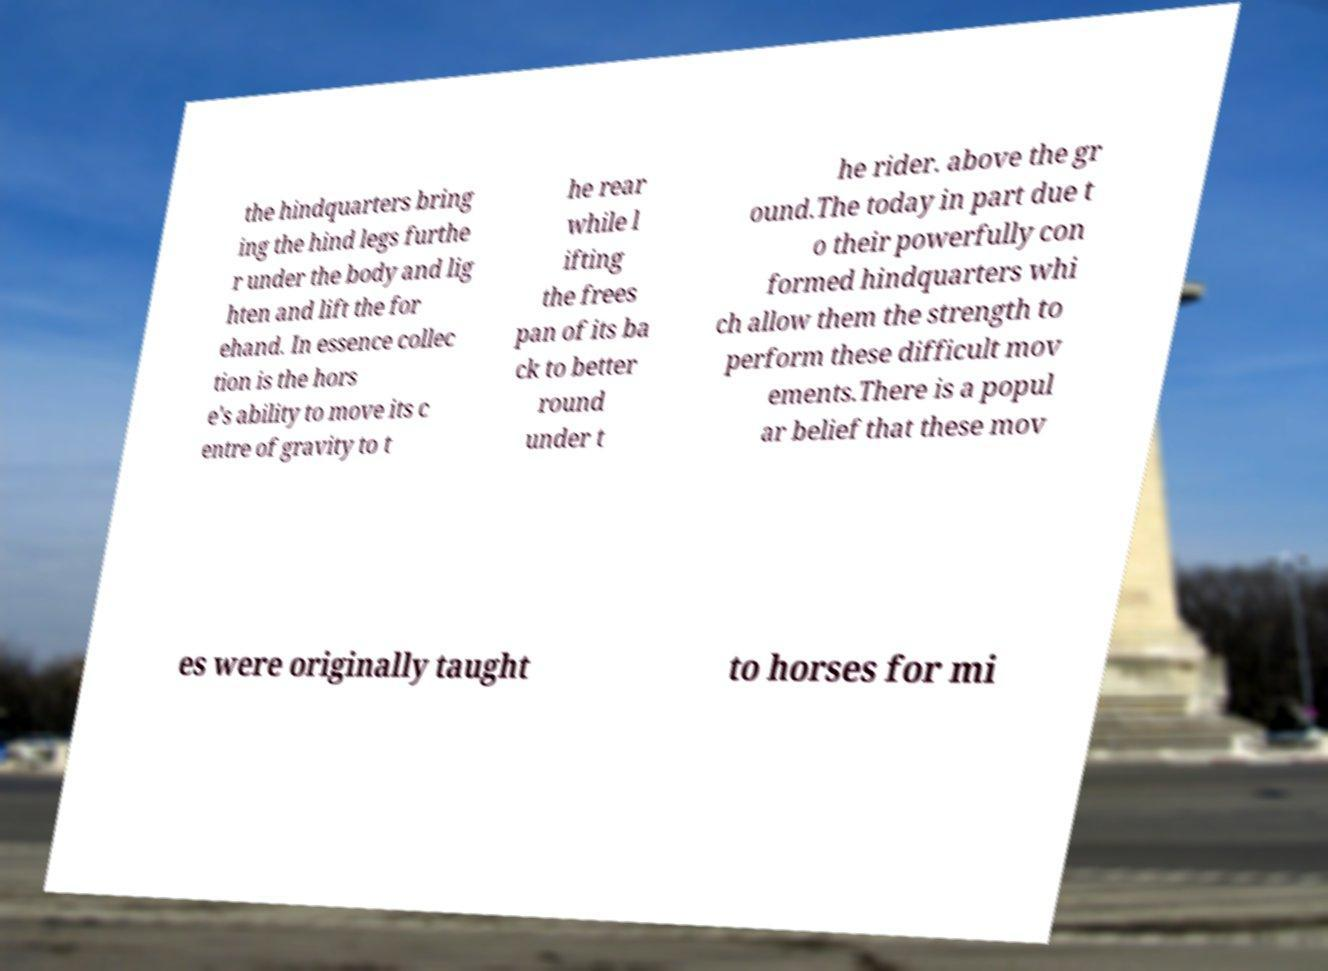Can you accurately transcribe the text from the provided image for me? the hindquarters bring ing the hind legs furthe r under the body and lig hten and lift the for ehand. In essence collec tion is the hors e's ability to move its c entre of gravity to t he rear while l ifting the frees pan of its ba ck to better round under t he rider. above the gr ound.The today in part due t o their powerfully con formed hindquarters whi ch allow them the strength to perform these difficult mov ements.There is a popul ar belief that these mov es were originally taught to horses for mi 